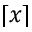<formula> <loc_0><loc_0><loc_500><loc_500>\lceil x \rceil</formula> 